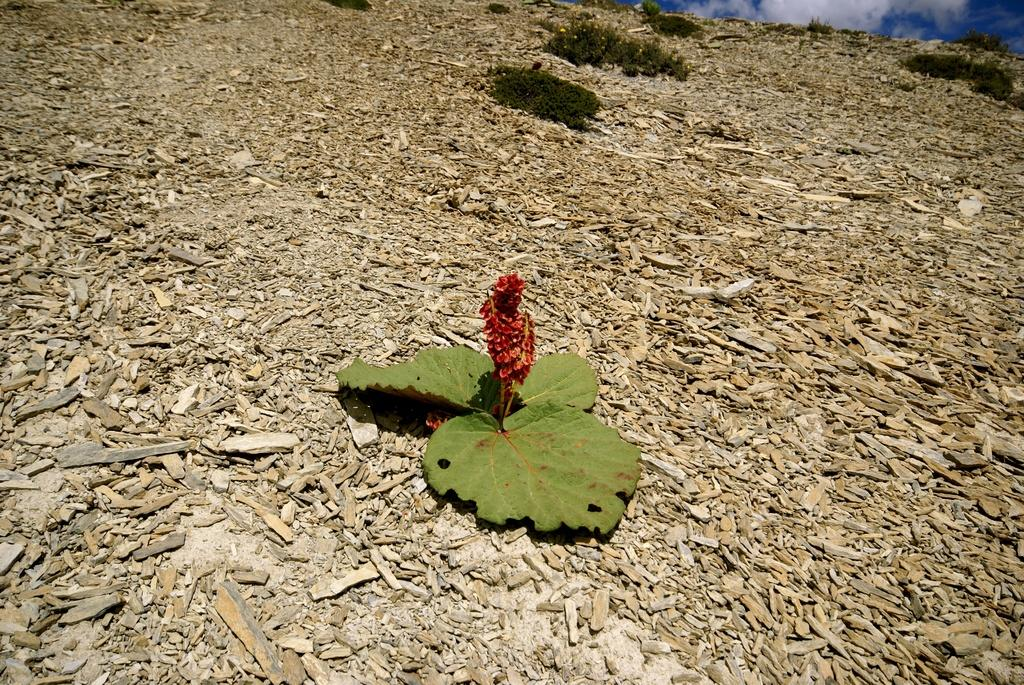What is the main subject in the center of the image? There is a plant in the center of the image. What can be seen at the bottom of the image? There are stones at the bottom of the image. What is visible in the background of the image? The sky is visible in the background of the image. Where is the flock of birds located in the image? There is no flock of birds present in the image. What type of shop can be seen in the image? There is no shop present in the image. 